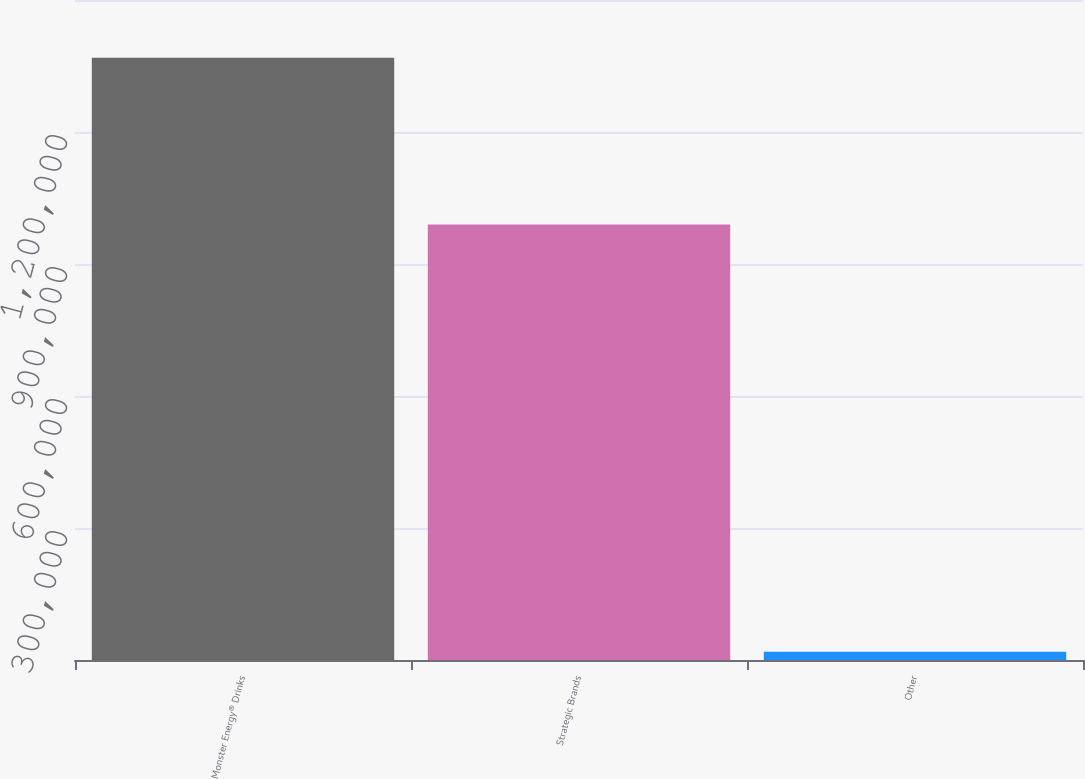Convert chart to OTSL. <chart><loc_0><loc_0><loc_500><loc_500><bar_chart><fcel>Monster Energy® Drinks<fcel>Strategic Brands<fcel>Other<nl><fcel>1.36862e+06<fcel>989944<fcel>18957<nl></chart> 